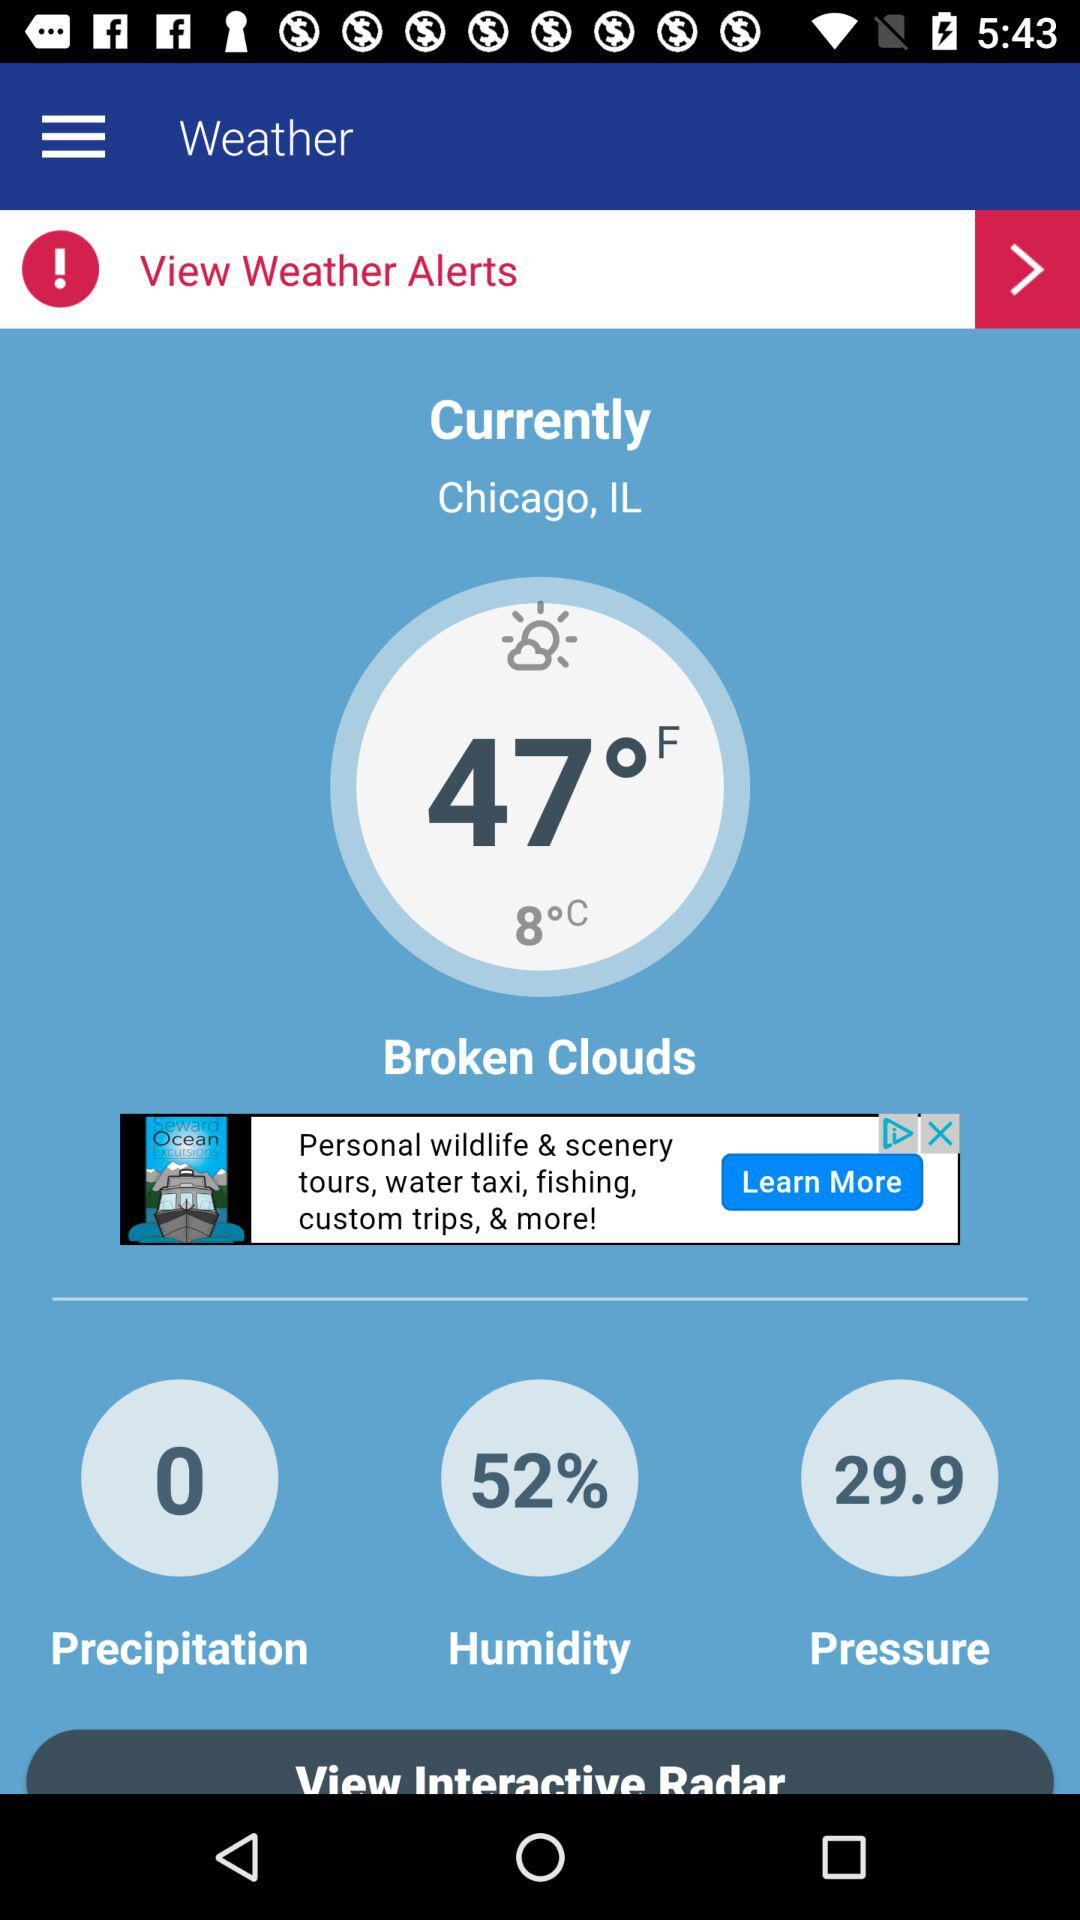What is the "Humidity" percentage? The percentage is 52. 